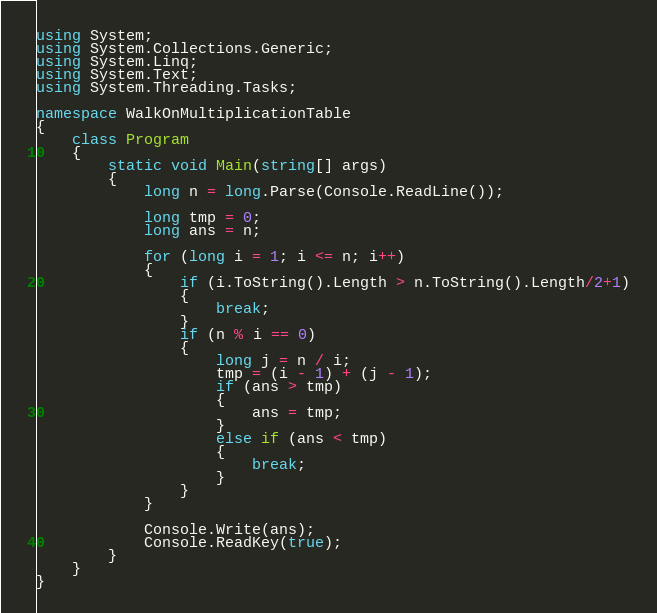Convert code to text. <code><loc_0><loc_0><loc_500><loc_500><_C#_>using System;
using System.Collections.Generic;
using System.Linq;
using System.Text;
using System.Threading.Tasks;

namespace WalkOnMultiplicationTable
{
    class Program
    {
        static void Main(string[] args)
        {
            long n = long.Parse(Console.ReadLine());

            long tmp = 0;
            long ans = n;
            
            for (long i = 1; i <= n; i++)
            {
                if (i.ToString().Length > n.ToString().Length/2+1)
                {   
                    break;
                }
                if (n % i == 0)
                {
                    long j = n / i;
                    tmp = (i - 1) + (j - 1);
                    if (ans > tmp)
                    {
                        ans = tmp;
                    }
                    else if (ans < tmp)
                    {
                        break;
                    }
                }
            }

            Console.Write(ans);
            Console.ReadKey(true);
        }
    }
}
</code> 